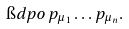<formula> <loc_0><loc_0><loc_500><loc_500>\i d p o \, p _ { \mu _ { 1 } } \dots p _ { \mu _ { n } } .</formula> 